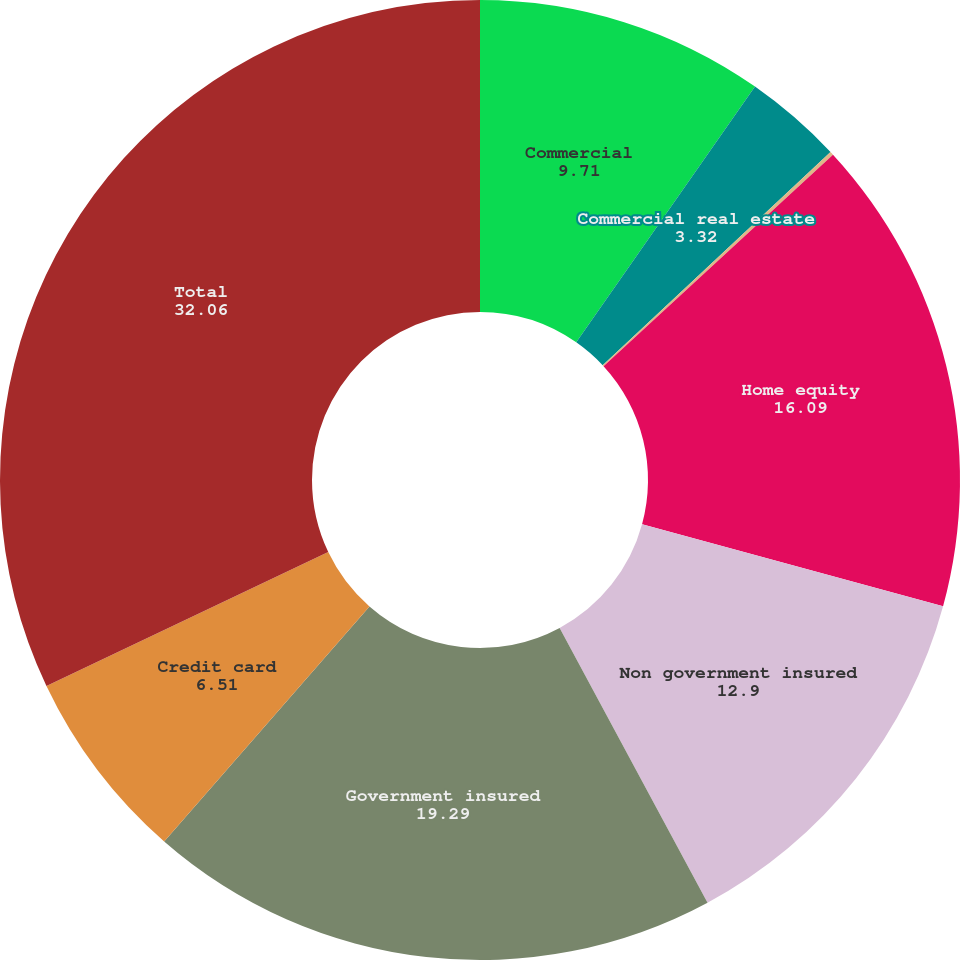<chart> <loc_0><loc_0><loc_500><loc_500><pie_chart><fcel>Commercial<fcel>Commercial real estate<fcel>Equipment lease financing<fcel>Home equity<fcel>Non government insured<fcel>Government insured<fcel>Credit card<fcel>Total<nl><fcel>9.71%<fcel>3.32%<fcel>0.12%<fcel>16.09%<fcel>12.9%<fcel>19.29%<fcel>6.51%<fcel>32.06%<nl></chart> 